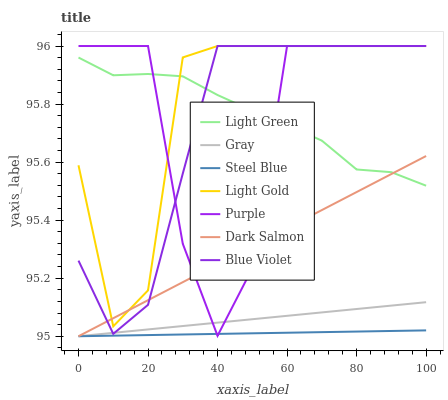Does Steel Blue have the minimum area under the curve?
Answer yes or no. Yes. Does Light Gold have the maximum area under the curve?
Answer yes or no. Yes. Does Purple have the minimum area under the curve?
Answer yes or no. No. Does Purple have the maximum area under the curve?
Answer yes or no. No. Is Gray the smoothest?
Answer yes or no. Yes. Is Purple the roughest?
Answer yes or no. Yes. Is Steel Blue the smoothest?
Answer yes or no. No. Is Steel Blue the roughest?
Answer yes or no. No. Does Gray have the lowest value?
Answer yes or no. Yes. Does Purple have the lowest value?
Answer yes or no. No. Does Blue Violet have the highest value?
Answer yes or no. Yes. Does Steel Blue have the highest value?
Answer yes or no. No. Is Gray less than Light Gold?
Answer yes or no. Yes. Is Light Green greater than Gray?
Answer yes or no. Yes. Does Light Gold intersect Purple?
Answer yes or no. Yes. Is Light Gold less than Purple?
Answer yes or no. No. Is Light Gold greater than Purple?
Answer yes or no. No. Does Gray intersect Light Gold?
Answer yes or no. No. 